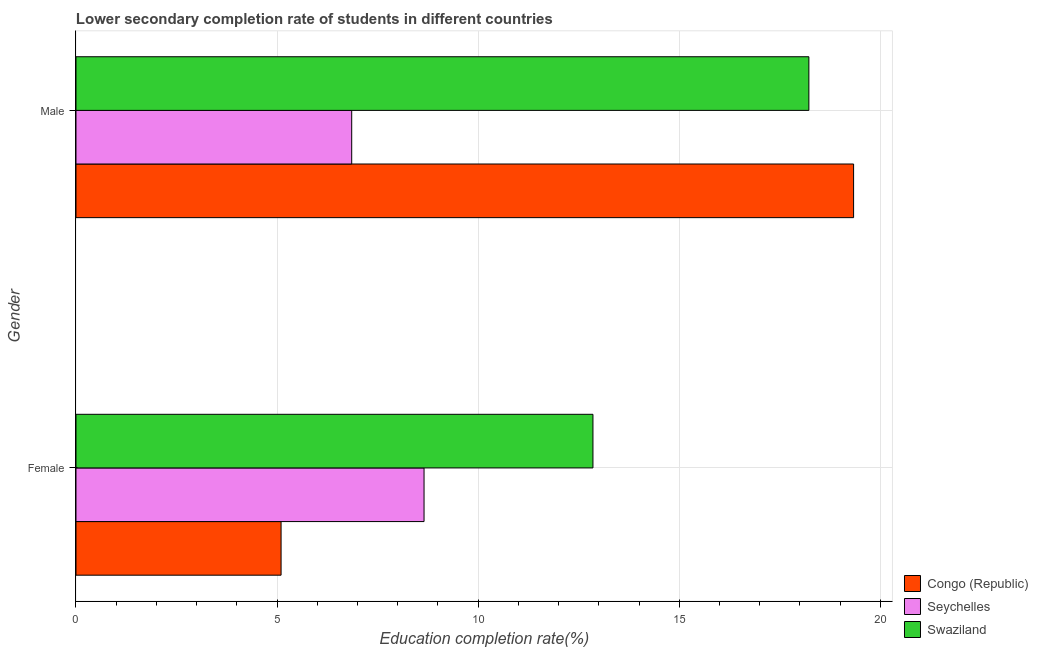How many different coloured bars are there?
Your answer should be compact. 3. Are the number of bars per tick equal to the number of legend labels?
Provide a short and direct response. Yes. Are the number of bars on each tick of the Y-axis equal?
Give a very brief answer. Yes. How many bars are there on the 2nd tick from the top?
Your answer should be compact. 3. What is the label of the 1st group of bars from the top?
Offer a terse response. Male. What is the education completion rate of female students in Congo (Republic)?
Keep it short and to the point. 5.1. Across all countries, what is the maximum education completion rate of male students?
Offer a very short reply. 19.33. Across all countries, what is the minimum education completion rate of male students?
Keep it short and to the point. 6.86. In which country was the education completion rate of male students maximum?
Give a very brief answer. Congo (Republic). In which country was the education completion rate of female students minimum?
Provide a short and direct response. Congo (Republic). What is the total education completion rate of male students in the graph?
Offer a terse response. 44.41. What is the difference between the education completion rate of male students in Swaziland and that in Congo (Republic)?
Provide a short and direct response. -1.11. What is the difference between the education completion rate of male students in Congo (Republic) and the education completion rate of female students in Seychelles?
Your answer should be compact. 10.68. What is the average education completion rate of female students per country?
Offer a terse response. 8.87. What is the difference between the education completion rate of female students and education completion rate of male students in Seychelles?
Provide a succinct answer. 1.8. What is the ratio of the education completion rate of female students in Congo (Republic) to that in Swaziland?
Give a very brief answer. 0.4. Is the education completion rate of male students in Congo (Republic) less than that in Seychelles?
Provide a succinct answer. No. In how many countries, is the education completion rate of male students greater than the average education completion rate of male students taken over all countries?
Provide a short and direct response. 2. What does the 1st bar from the top in Female represents?
Your response must be concise. Swaziland. What does the 3rd bar from the bottom in Male represents?
Provide a short and direct response. Swaziland. What is the difference between two consecutive major ticks on the X-axis?
Your answer should be compact. 5. Are the values on the major ticks of X-axis written in scientific E-notation?
Provide a short and direct response. No. Does the graph contain any zero values?
Your response must be concise. No. Does the graph contain grids?
Provide a short and direct response. Yes. Where does the legend appear in the graph?
Offer a terse response. Bottom right. How are the legend labels stacked?
Your response must be concise. Vertical. What is the title of the graph?
Offer a terse response. Lower secondary completion rate of students in different countries. What is the label or title of the X-axis?
Provide a short and direct response. Education completion rate(%). What is the label or title of the Y-axis?
Your answer should be compact. Gender. What is the Education completion rate(%) in Congo (Republic) in Female?
Give a very brief answer. 5.1. What is the Education completion rate(%) in Seychelles in Female?
Your answer should be compact. 8.65. What is the Education completion rate(%) of Swaziland in Female?
Your response must be concise. 12.85. What is the Education completion rate(%) of Congo (Republic) in Male?
Offer a very short reply. 19.33. What is the Education completion rate(%) in Seychelles in Male?
Give a very brief answer. 6.86. What is the Education completion rate(%) of Swaziland in Male?
Offer a very short reply. 18.22. Across all Gender, what is the maximum Education completion rate(%) in Congo (Republic)?
Provide a succinct answer. 19.33. Across all Gender, what is the maximum Education completion rate(%) in Seychelles?
Your answer should be compact. 8.65. Across all Gender, what is the maximum Education completion rate(%) of Swaziland?
Provide a short and direct response. 18.22. Across all Gender, what is the minimum Education completion rate(%) in Congo (Republic)?
Give a very brief answer. 5.1. Across all Gender, what is the minimum Education completion rate(%) of Seychelles?
Give a very brief answer. 6.86. Across all Gender, what is the minimum Education completion rate(%) of Swaziland?
Make the answer very short. 12.85. What is the total Education completion rate(%) of Congo (Republic) in the graph?
Ensure brevity in your answer.  24.43. What is the total Education completion rate(%) in Seychelles in the graph?
Your answer should be compact. 15.51. What is the total Education completion rate(%) in Swaziland in the graph?
Provide a short and direct response. 31.08. What is the difference between the Education completion rate(%) of Congo (Republic) in Female and that in Male?
Your answer should be very brief. -14.23. What is the difference between the Education completion rate(%) in Seychelles in Female and that in Male?
Your answer should be very brief. 1.8. What is the difference between the Education completion rate(%) of Swaziland in Female and that in Male?
Make the answer very short. -5.37. What is the difference between the Education completion rate(%) of Congo (Republic) in Female and the Education completion rate(%) of Seychelles in Male?
Your answer should be very brief. -1.76. What is the difference between the Education completion rate(%) in Congo (Republic) in Female and the Education completion rate(%) in Swaziland in Male?
Provide a succinct answer. -13.12. What is the difference between the Education completion rate(%) of Seychelles in Female and the Education completion rate(%) of Swaziland in Male?
Your response must be concise. -9.57. What is the average Education completion rate(%) of Congo (Republic) per Gender?
Provide a succinct answer. 12.22. What is the average Education completion rate(%) of Seychelles per Gender?
Keep it short and to the point. 7.75. What is the average Education completion rate(%) in Swaziland per Gender?
Offer a terse response. 15.54. What is the difference between the Education completion rate(%) in Congo (Republic) and Education completion rate(%) in Seychelles in Female?
Ensure brevity in your answer.  -3.55. What is the difference between the Education completion rate(%) in Congo (Republic) and Education completion rate(%) in Swaziland in Female?
Offer a terse response. -7.75. What is the difference between the Education completion rate(%) of Seychelles and Education completion rate(%) of Swaziland in Female?
Provide a succinct answer. -4.2. What is the difference between the Education completion rate(%) of Congo (Republic) and Education completion rate(%) of Seychelles in Male?
Offer a terse response. 12.48. What is the difference between the Education completion rate(%) in Congo (Republic) and Education completion rate(%) in Swaziland in Male?
Ensure brevity in your answer.  1.11. What is the difference between the Education completion rate(%) in Seychelles and Education completion rate(%) in Swaziland in Male?
Your answer should be compact. -11.37. What is the ratio of the Education completion rate(%) in Congo (Republic) in Female to that in Male?
Make the answer very short. 0.26. What is the ratio of the Education completion rate(%) in Seychelles in Female to that in Male?
Ensure brevity in your answer.  1.26. What is the ratio of the Education completion rate(%) in Swaziland in Female to that in Male?
Keep it short and to the point. 0.71. What is the difference between the highest and the second highest Education completion rate(%) in Congo (Republic)?
Provide a succinct answer. 14.24. What is the difference between the highest and the second highest Education completion rate(%) in Seychelles?
Make the answer very short. 1.8. What is the difference between the highest and the second highest Education completion rate(%) in Swaziland?
Give a very brief answer. 5.37. What is the difference between the highest and the lowest Education completion rate(%) of Congo (Republic)?
Your answer should be compact. 14.23. What is the difference between the highest and the lowest Education completion rate(%) in Seychelles?
Provide a short and direct response. 1.8. What is the difference between the highest and the lowest Education completion rate(%) in Swaziland?
Give a very brief answer. 5.37. 